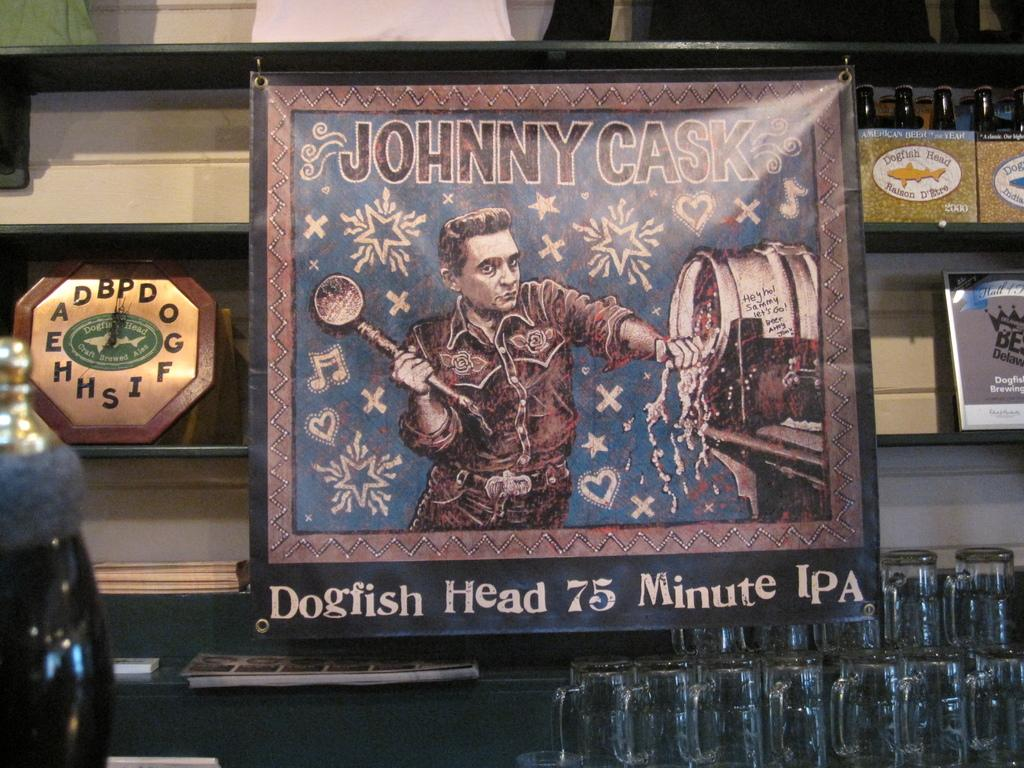<image>
Present a compact description of the photo's key features. A picture is titled Johnny Cask and shows a man next to a barrel. 